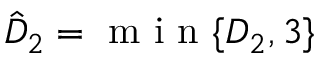<formula> <loc_0><loc_0><loc_500><loc_500>\hat { D } _ { 2 } = m i n \{ D _ { 2 } , { 3 } \}</formula> 